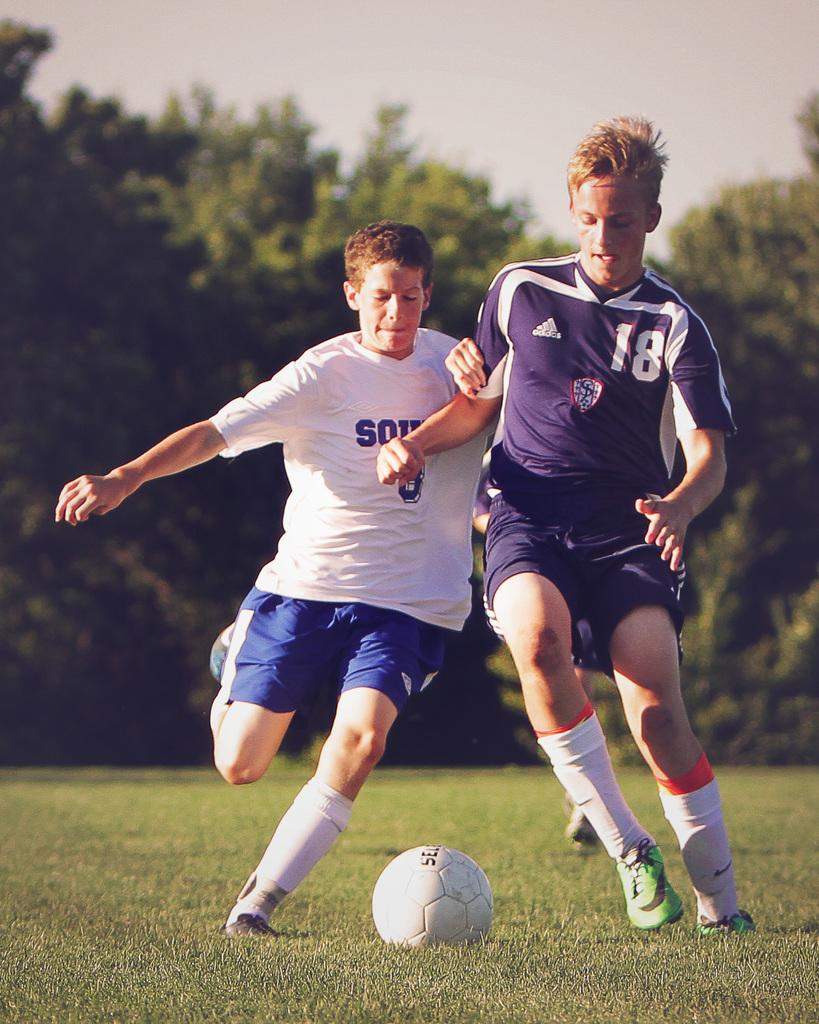How many people are playing football in the image? There are three players in the image. What sport are the players engaged in? The players are playing football. What is the main object used in the game? There is a football in the image. What can be seen in the background of the image? There are trees in the background of the image. What type of animal can be seen playing football with the players in the image? There are no animals present in the image; the players are the only subjects involved in the game of football. 